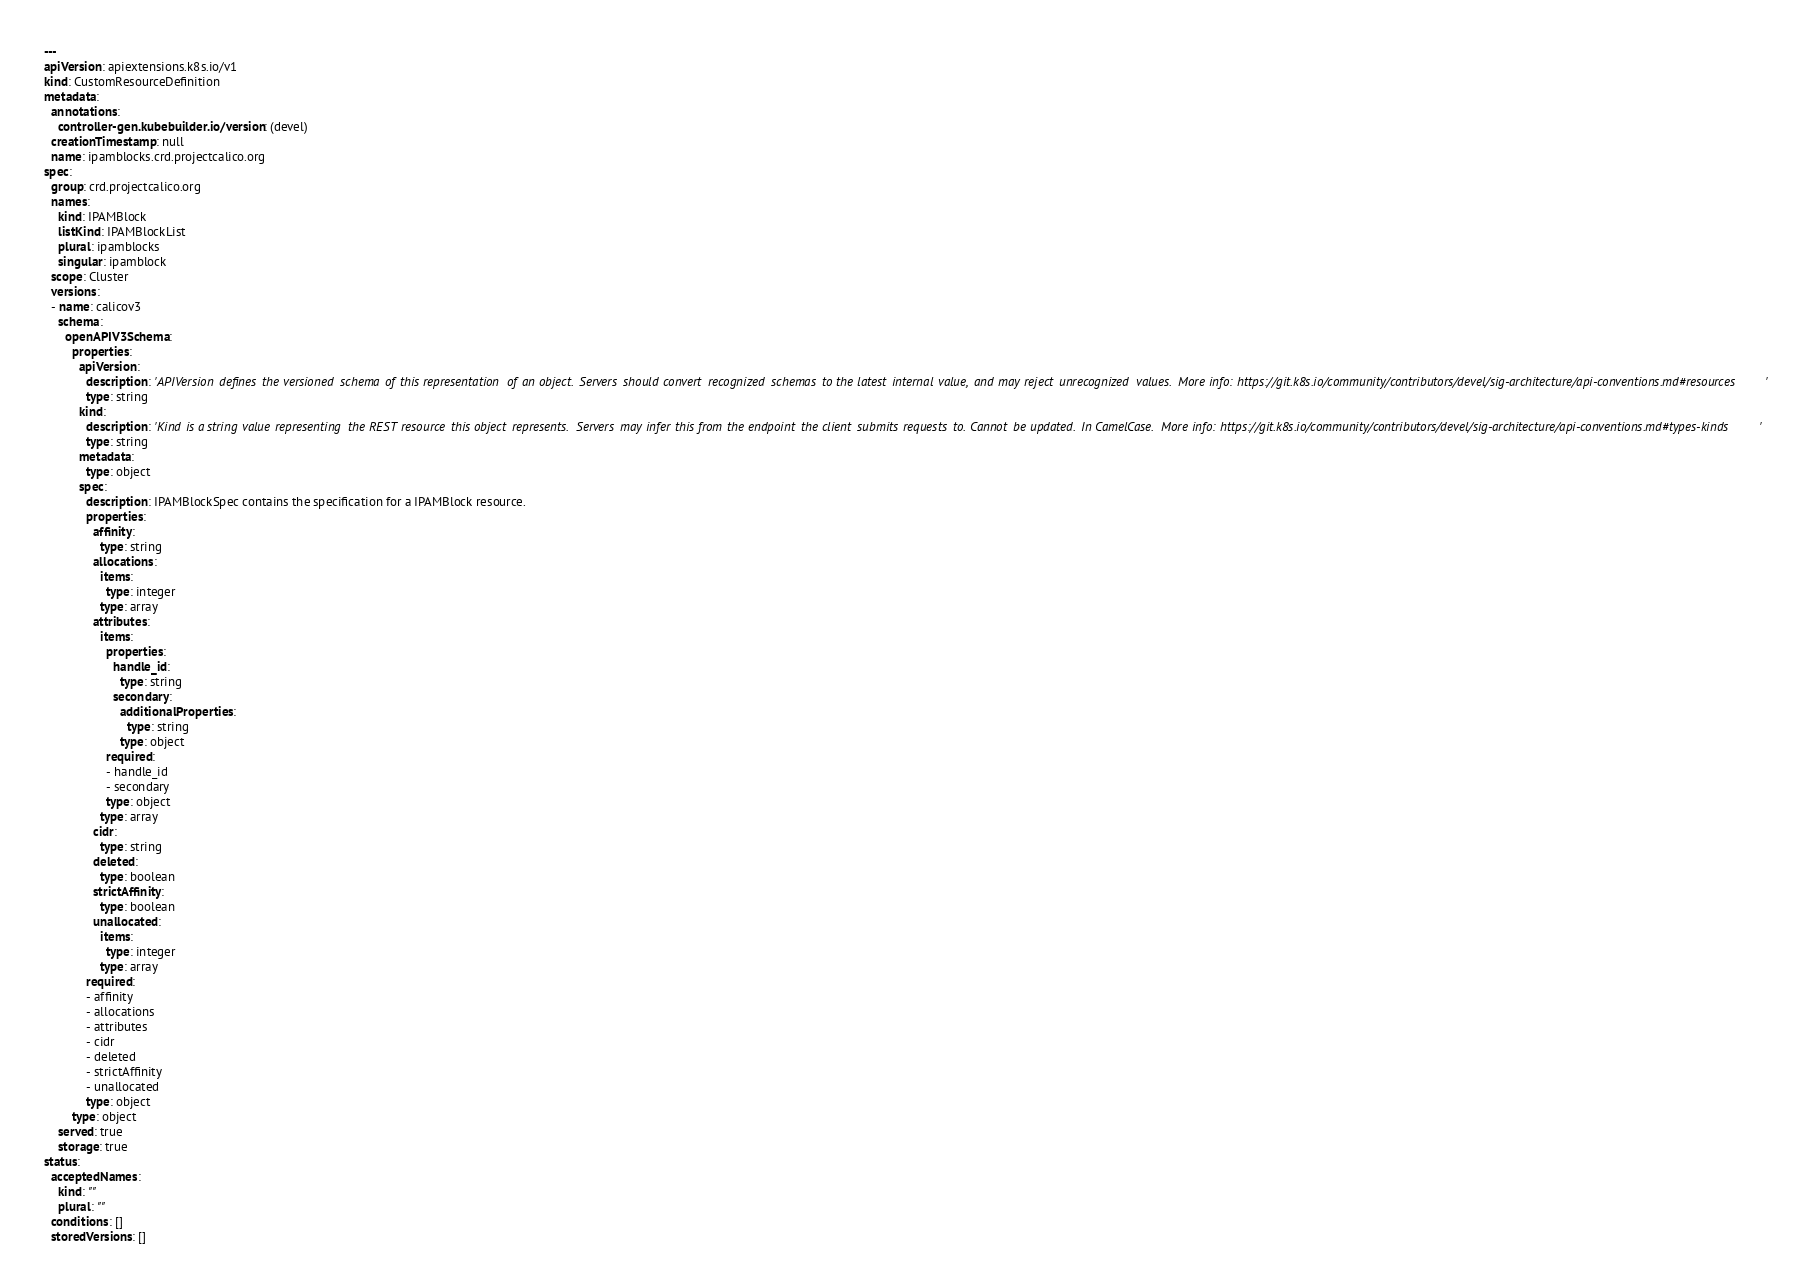Convert code to text. <code><loc_0><loc_0><loc_500><loc_500><_YAML_>
---
apiVersion: apiextensions.k8s.io/v1
kind: CustomResourceDefinition
metadata:
  annotations:
    controller-gen.kubebuilder.io/version: (devel)
  creationTimestamp: null
  name: ipamblocks.crd.projectcalico.org
spec:
  group: crd.projectcalico.org
  names:
    kind: IPAMBlock
    listKind: IPAMBlockList
    plural: ipamblocks
    singular: ipamblock
  scope: Cluster
  versions:
  - name: calicov3
    schema:
      openAPIV3Schema:
        properties:
          apiVersion:
            description: 'APIVersion defines the versioned schema of this representation of an object. Servers should convert recognized schemas to the latest internal value, and may reject unrecognized values. More info: https://git.k8s.io/community/contributors/devel/sig-architecture/api-conventions.md#resources'
            type: string
          kind:
            description: 'Kind is a string value representing the REST resource this object represents. Servers may infer this from the endpoint the client submits requests to. Cannot be updated. In CamelCase. More info: https://git.k8s.io/community/contributors/devel/sig-architecture/api-conventions.md#types-kinds'
            type: string
          metadata:
            type: object
          spec:
            description: IPAMBlockSpec contains the specification for a IPAMBlock resource.
            properties:
              affinity:
                type: string
              allocations:
                items:
                  type: integer
                type: array
              attributes:
                items:
                  properties:
                    handle_id:
                      type: string
                    secondary:
                      additionalProperties:
                        type: string
                      type: object
                  required:
                  - handle_id
                  - secondary
                  type: object
                type: array
              cidr:
                type: string
              deleted:
                type: boolean
              strictAffinity:
                type: boolean
              unallocated:
                items:
                  type: integer
                type: array
            required:
            - affinity
            - allocations
            - attributes
            - cidr
            - deleted
            - strictAffinity
            - unallocated
            type: object
        type: object
    served: true
    storage: true
status:
  acceptedNames:
    kind: ""
    plural: ""
  conditions: []
  storedVersions: []
</code> 